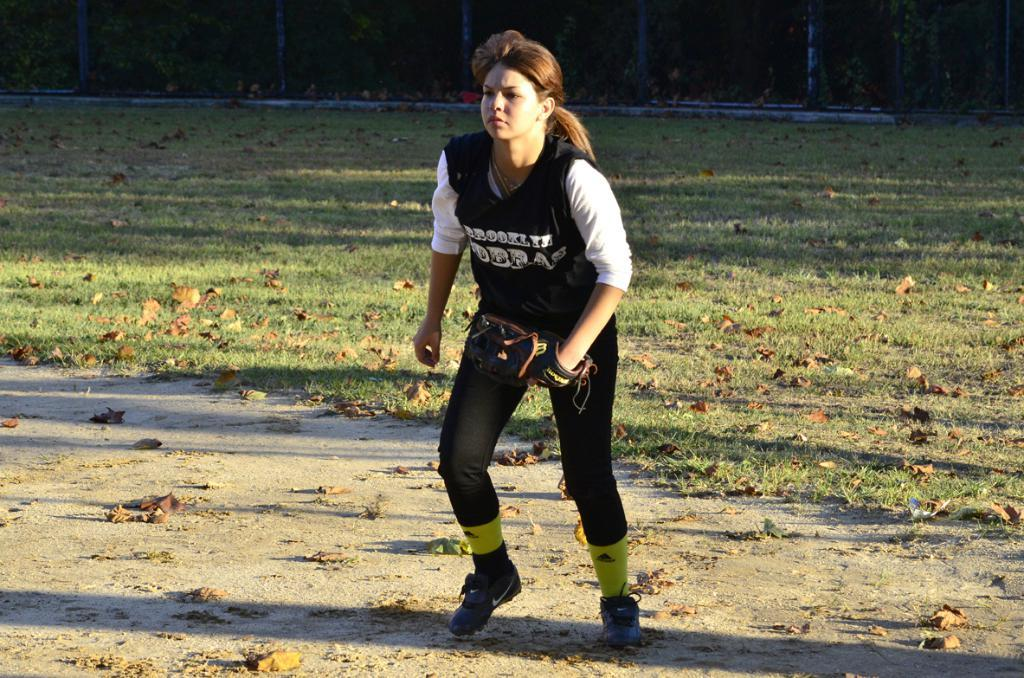Who is present in the image? There is a woman in the image. What is the woman wearing on her hand? The woman is wearing a baseball glove. What can be seen on the ground in the image? There are dry leaves and grass on the ground. What is visible in the background of the image? There is a fence in the background of the image. Reasoning: Let' Let's think step by step in order to produce the conversation. We start by identifying the main subject in the image, which is the woman. Then, we describe what she is wearing, which is a baseball glove. Next, we mention the details of the ground, including the dry leaves and grass. Finally, we focus on the background of the image, where a fence is visible. Each question is designed to elicit a specific detail about the image that is known from the provided facts. Absurd Question/Answer: What type of vegetable is growing near the fence in the image? There is no vegetable growing near the fence in the image. Can you see a snail crawling on the woman's baseball glove in the image? There is no snail visible on the woman's baseball glove in the image. 